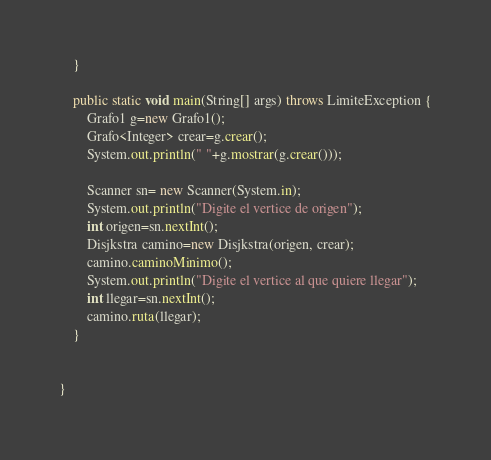<code> <loc_0><loc_0><loc_500><loc_500><_Java_>    }
    
    public static void main(String[] args) throws LimiteException {
        Grafo1 g=new Grafo1();
        Grafo<Integer> crear=g.crear();
        System.out.println(" "+g.mostrar(g.crear()));
        
        Scanner sn= new Scanner(System.in);
        System.out.println("Digite el vertice de origen");
        int origen=sn.nextInt();
        Disjkstra camino=new Disjkstra(origen, crear);
        camino.caminoMinimo();
        System.out.println("Digite el vertice al que quiere llegar");
        int llegar=sn.nextInt();
        camino.ruta(llegar);
    }

    
}
</code> 